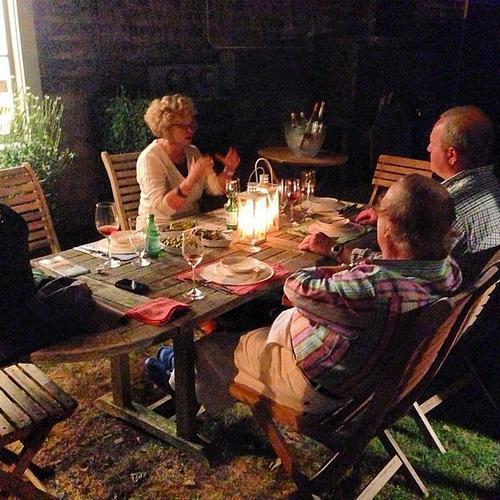How many people?
Give a very brief answer. 3. 